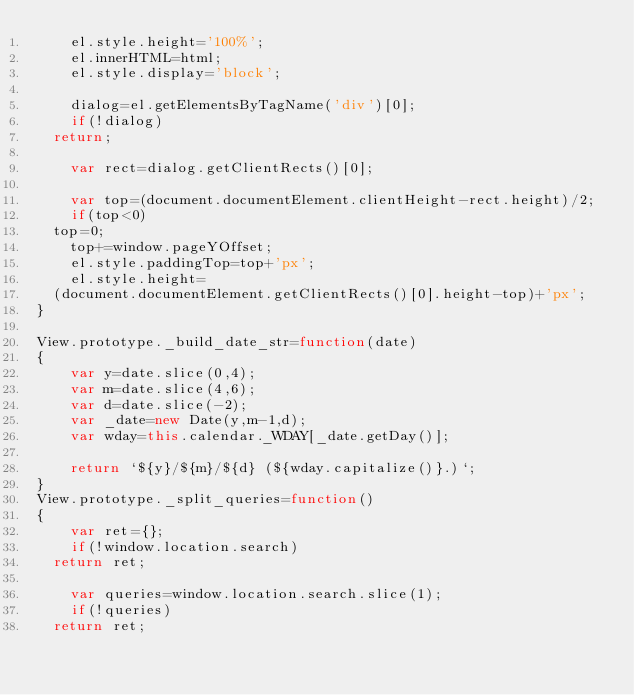<code> <loc_0><loc_0><loc_500><loc_500><_JavaScript_>    el.style.height='100%';
    el.innerHTML=html;
    el.style.display='block';

    dialog=el.getElementsByTagName('div')[0];
    if(!dialog)
	return;

    var rect=dialog.getClientRects()[0];
 
    var top=(document.documentElement.clientHeight-rect.height)/2;
    if(top<0)
	top=0;
    top+=window.pageYOffset;
    el.style.paddingTop=top+'px';
    el.style.height=
	(document.documentElement.getClientRects()[0].height-top)+'px';
}

View.prototype._build_date_str=function(date)
{
    var y=date.slice(0,4);
    var m=date.slice(4,6);
    var d=date.slice(-2);
    var _date=new Date(y,m-1,d);
    var wday=this.calendar._WDAY[_date.getDay()];

    return `${y}/${m}/${d} (${wday.capitalize()}.)`;
}
View.prototype._split_queries=function()
{
    var ret={};
    if(!window.location.search)
	return ret;

    var queries=window.location.search.slice(1);
    if(!queries)
	return ret;
</code> 